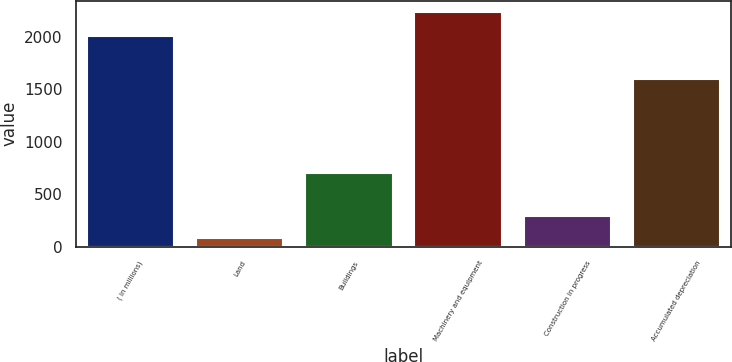<chart> <loc_0><loc_0><loc_500><loc_500><bar_chart><fcel>( in millions)<fcel>Land<fcel>Buildings<fcel>Machinery and equipment<fcel>Construction in progress<fcel>Accumulated depreciation<nl><fcel>2005<fcel>77.2<fcel>700.6<fcel>2231.4<fcel>292.62<fcel>1596.8<nl></chart> 